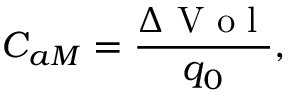<formula> <loc_0><loc_0><loc_500><loc_500>C _ { a M } = \frac { \Delta V o l } { q _ { 0 } } ,</formula> 